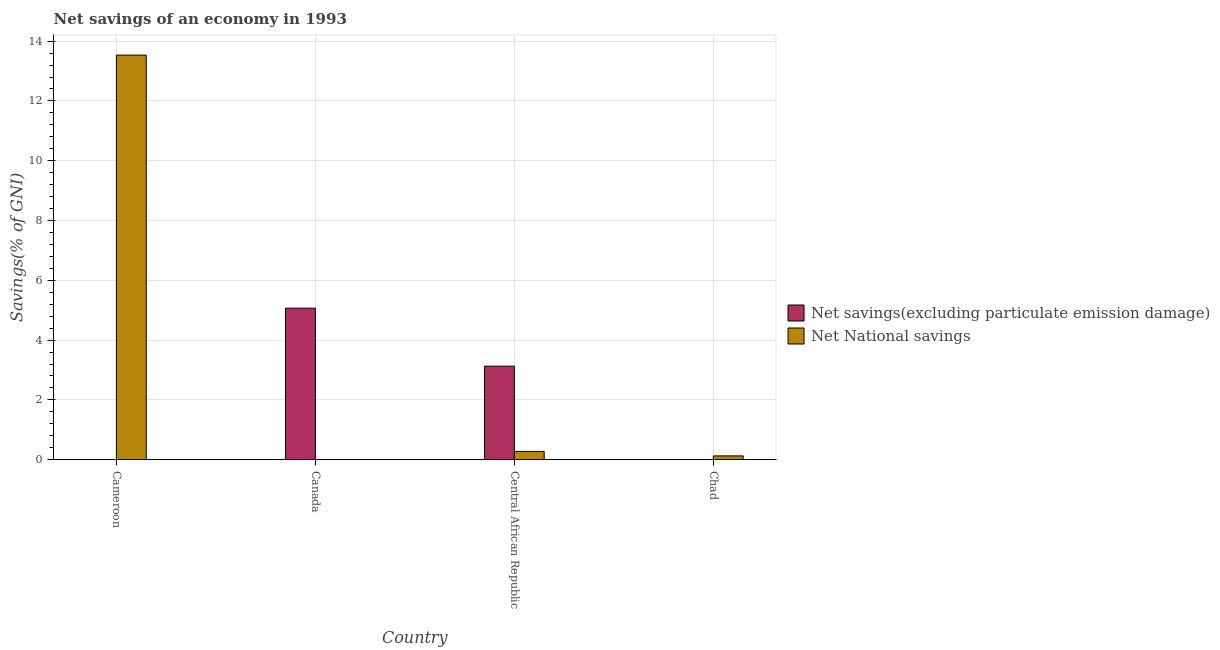How many different coloured bars are there?
Offer a terse response. 2. Are the number of bars per tick equal to the number of legend labels?
Your response must be concise. No. What is the net savings(excluding particulate emission damage) in Central African Republic?
Keep it short and to the point. 3.13. Across all countries, what is the maximum net national savings?
Provide a short and direct response. 13.53. Across all countries, what is the minimum net savings(excluding particulate emission damage)?
Offer a terse response. 0. In which country was the net savings(excluding particulate emission damage) maximum?
Provide a succinct answer. Canada. What is the total net savings(excluding particulate emission damage) in the graph?
Your answer should be compact. 8.2. What is the difference between the net national savings in Cameroon and that in Central African Republic?
Keep it short and to the point. 13.26. What is the difference between the net national savings in Chad and the net savings(excluding particulate emission damage) in Canada?
Provide a succinct answer. -4.94. What is the average net savings(excluding particulate emission damage) per country?
Your response must be concise. 2.05. What is the difference between the net savings(excluding particulate emission damage) and net national savings in Central African Republic?
Ensure brevity in your answer.  2.85. What is the ratio of the net savings(excluding particulate emission damage) in Canada to that in Central African Republic?
Provide a succinct answer. 1.62. What is the difference between the highest and the second highest net national savings?
Your response must be concise. 13.26. What is the difference between the highest and the lowest net savings(excluding particulate emission damage)?
Your answer should be very brief. 5.07. Are all the bars in the graph horizontal?
Your answer should be compact. No. How many countries are there in the graph?
Your response must be concise. 4. Are the values on the major ticks of Y-axis written in scientific E-notation?
Make the answer very short. No. Does the graph contain grids?
Make the answer very short. Yes. How many legend labels are there?
Keep it short and to the point. 2. What is the title of the graph?
Provide a succinct answer. Net savings of an economy in 1993. What is the label or title of the Y-axis?
Make the answer very short. Savings(% of GNI). What is the Savings(% of GNI) of Net savings(excluding particulate emission damage) in Cameroon?
Ensure brevity in your answer.  0. What is the Savings(% of GNI) in Net National savings in Cameroon?
Offer a terse response. 13.53. What is the Savings(% of GNI) in Net savings(excluding particulate emission damage) in Canada?
Your answer should be very brief. 5.07. What is the Savings(% of GNI) of Net National savings in Canada?
Offer a terse response. 0. What is the Savings(% of GNI) in Net savings(excluding particulate emission damage) in Central African Republic?
Offer a very short reply. 3.13. What is the Savings(% of GNI) of Net National savings in Central African Republic?
Ensure brevity in your answer.  0.28. What is the Savings(% of GNI) of Net National savings in Chad?
Your answer should be very brief. 0.13. Across all countries, what is the maximum Savings(% of GNI) of Net savings(excluding particulate emission damage)?
Offer a terse response. 5.07. Across all countries, what is the maximum Savings(% of GNI) in Net National savings?
Give a very brief answer. 13.53. Across all countries, what is the minimum Savings(% of GNI) of Net savings(excluding particulate emission damage)?
Ensure brevity in your answer.  0. What is the total Savings(% of GNI) in Net savings(excluding particulate emission damage) in the graph?
Ensure brevity in your answer.  8.2. What is the total Savings(% of GNI) in Net National savings in the graph?
Provide a succinct answer. 13.94. What is the difference between the Savings(% of GNI) in Net National savings in Cameroon and that in Central African Republic?
Keep it short and to the point. 13.26. What is the difference between the Savings(% of GNI) in Net National savings in Cameroon and that in Chad?
Your answer should be very brief. 13.41. What is the difference between the Savings(% of GNI) of Net savings(excluding particulate emission damage) in Canada and that in Central African Republic?
Provide a short and direct response. 1.94. What is the difference between the Savings(% of GNI) of Net National savings in Central African Republic and that in Chad?
Give a very brief answer. 0.15. What is the difference between the Savings(% of GNI) of Net savings(excluding particulate emission damage) in Canada and the Savings(% of GNI) of Net National savings in Central African Republic?
Offer a terse response. 4.79. What is the difference between the Savings(% of GNI) in Net savings(excluding particulate emission damage) in Canada and the Savings(% of GNI) in Net National savings in Chad?
Your response must be concise. 4.94. What is the difference between the Savings(% of GNI) of Net savings(excluding particulate emission damage) in Central African Republic and the Savings(% of GNI) of Net National savings in Chad?
Provide a short and direct response. 3. What is the average Savings(% of GNI) in Net savings(excluding particulate emission damage) per country?
Offer a terse response. 2.05. What is the average Savings(% of GNI) of Net National savings per country?
Your response must be concise. 3.48. What is the difference between the Savings(% of GNI) of Net savings(excluding particulate emission damage) and Savings(% of GNI) of Net National savings in Central African Republic?
Give a very brief answer. 2.85. What is the ratio of the Savings(% of GNI) of Net National savings in Cameroon to that in Central African Republic?
Provide a succinct answer. 48.88. What is the ratio of the Savings(% of GNI) in Net National savings in Cameroon to that in Chad?
Keep it short and to the point. 106.43. What is the ratio of the Savings(% of GNI) in Net savings(excluding particulate emission damage) in Canada to that in Central African Republic?
Offer a very short reply. 1.62. What is the ratio of the Savings(% of GNI) in Net National savings in Central African Republic to that in Chad?
Provide a short and direct response. 2.18. What is the difference between the highest and the second highest Savings(% of GNI) of Net National savings?
Offer a terse response. 13.26. What is the difference between the highest and the lowest Savings(% of GNI) of Net savings(excluding particulate emission damage)?
Offer a terse response. 5.07. What is the difference between the highest and the lowest Savings(% of GNI) of Net National savings?
Your response must be concise. 13.53. 